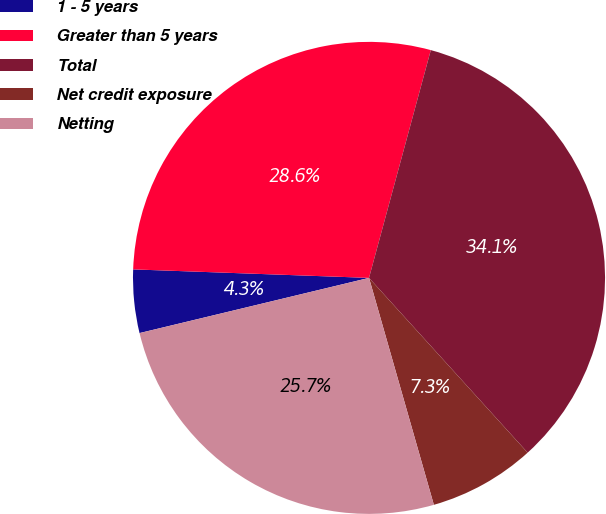Convert chart. <chart><loc_0><loc_0><loc_500><loc_500><pie_chart><fcel>1 - 5 years<fcel>Greater than 5 years<fcel>Total<fcel>Net credit exposure<fcel>Netting<nl><fcel>4.33%<fcel>28.64%<fcel>34.05%<fcel>7.3%<fcel>25.67%<nl></chart> 